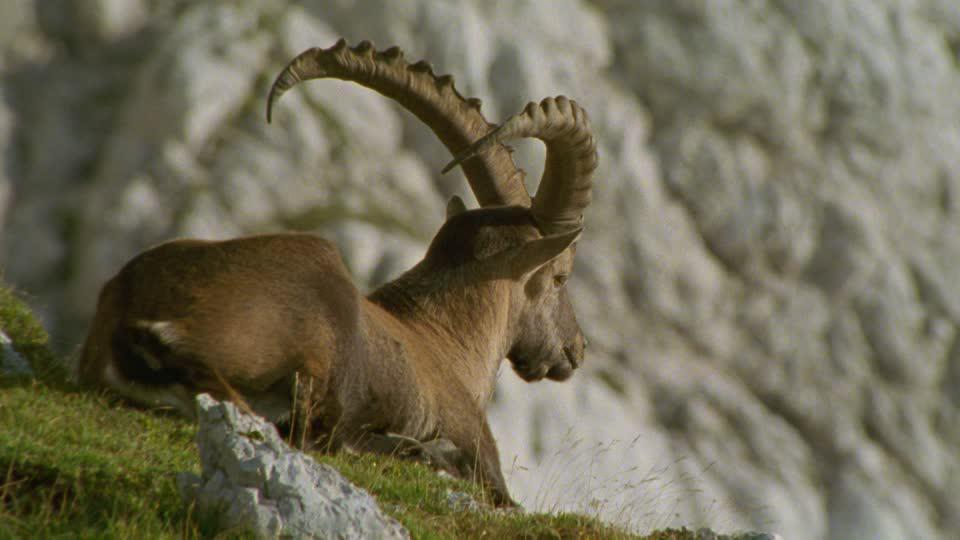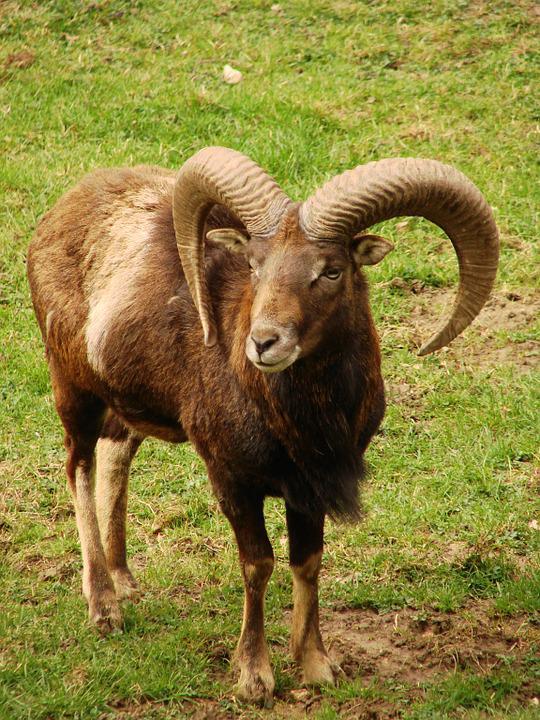The first image is the image on the left, the second image is the image on the right. Evaluate the accuracy of this statement regarding the images: "An image shows a younger goat standing near an adult goat.". Is it true? Answer yes or no. No. 